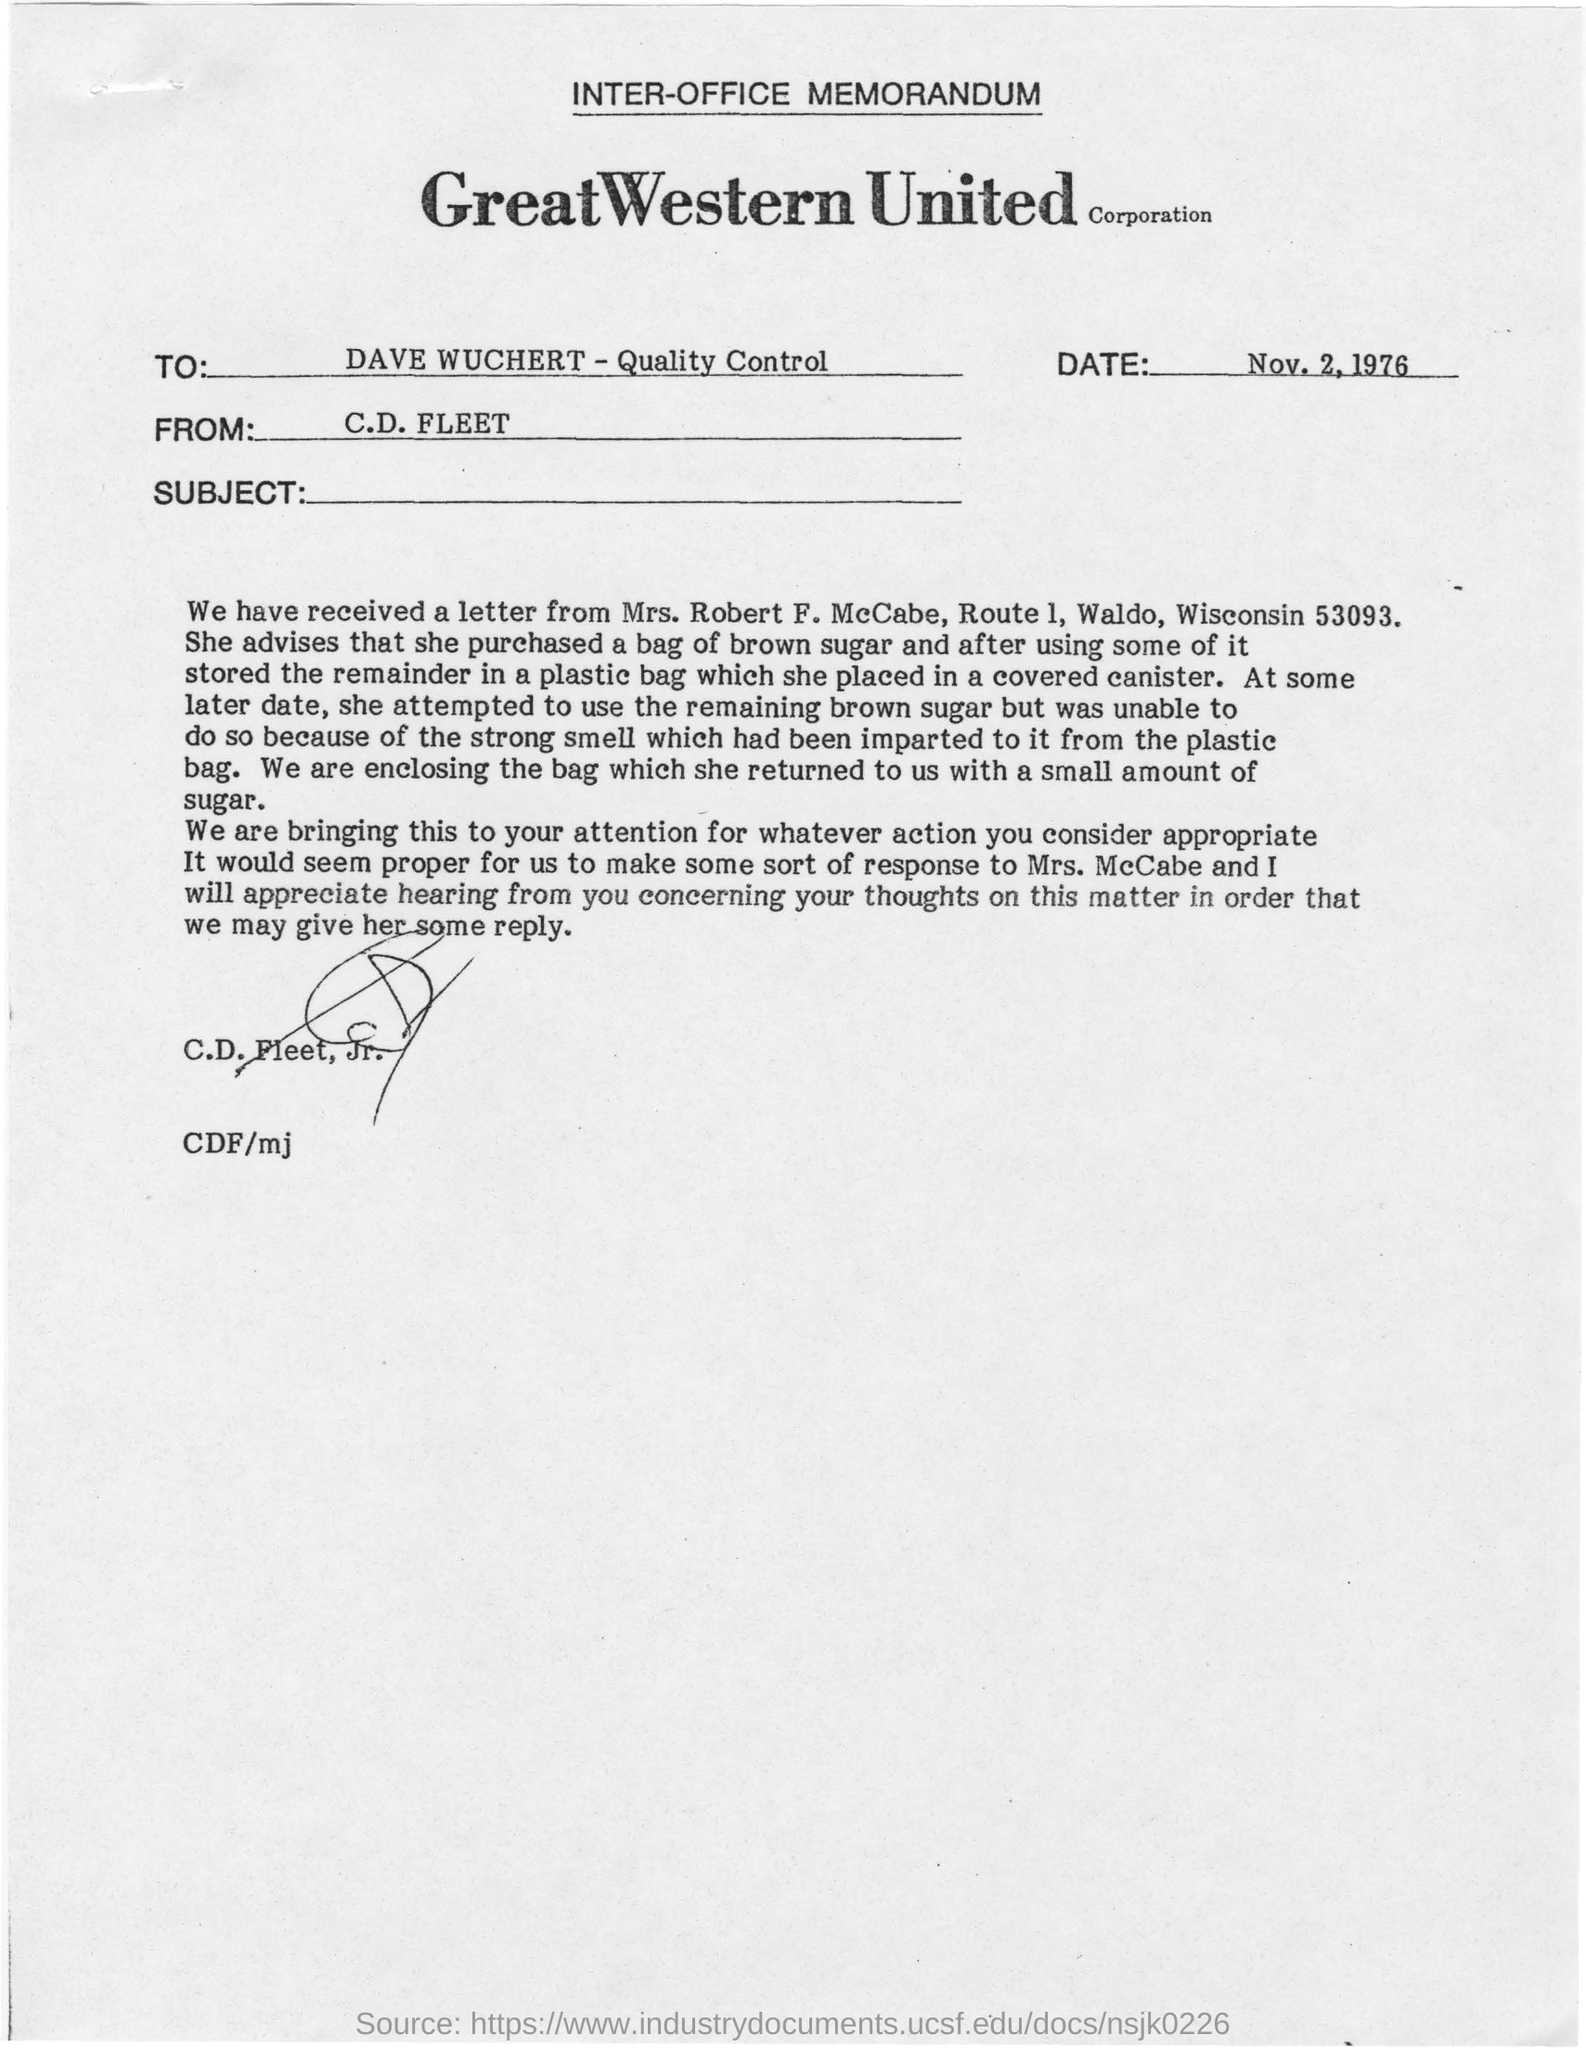When is the memorandum dated on?
Offer a very short reply. Nov. 2, 1976. Who is the memorandum from?
Offer a very short reply. C.D. Fleet. To whom is the memorandum addressed to?
Ensure brevity in your answer.  Dave Wuchert - Quality Control. 